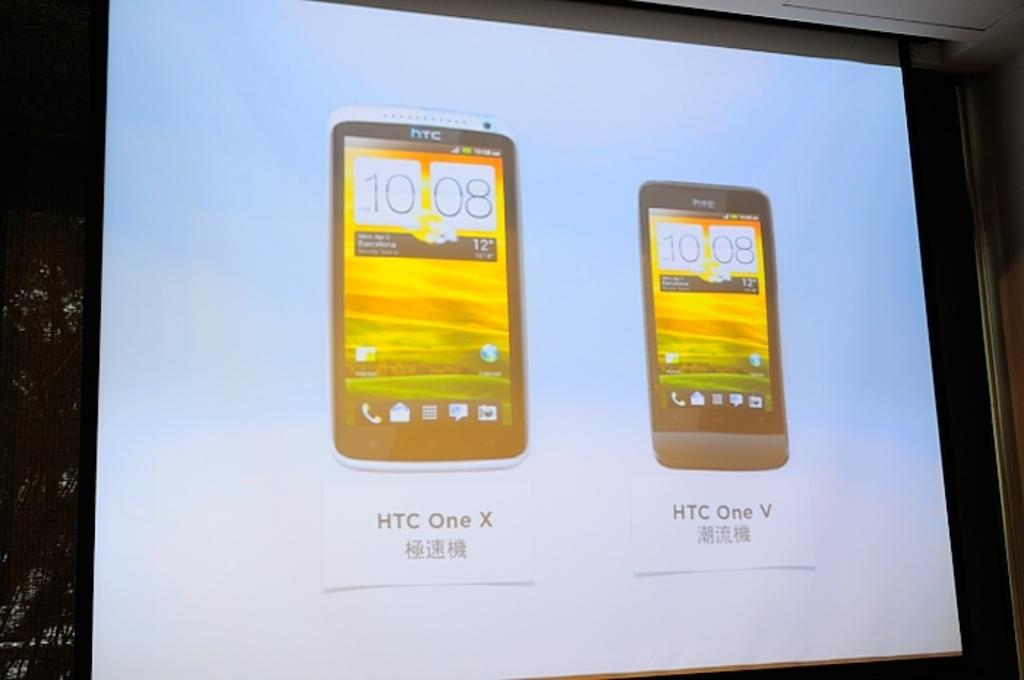Provide a one-sentence caption for the provided image. Two cell phones from HTC displayed on a projector screen. 